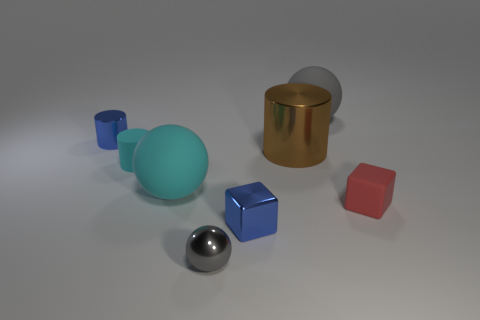Add 2 large gray balls. How many objects exist? 10 Subtract all balls. How many objects are left? 5 Add 2 gray shiny balls. How many gray shiny balls are left? 3 Add 8 brown blocks. How many brown blocks exist? 8 Subtract 1 blue cylinders. How many objects are left? 7 Subtract all cylinders. Subtract all small rubber objects. How many objects are left? 3 